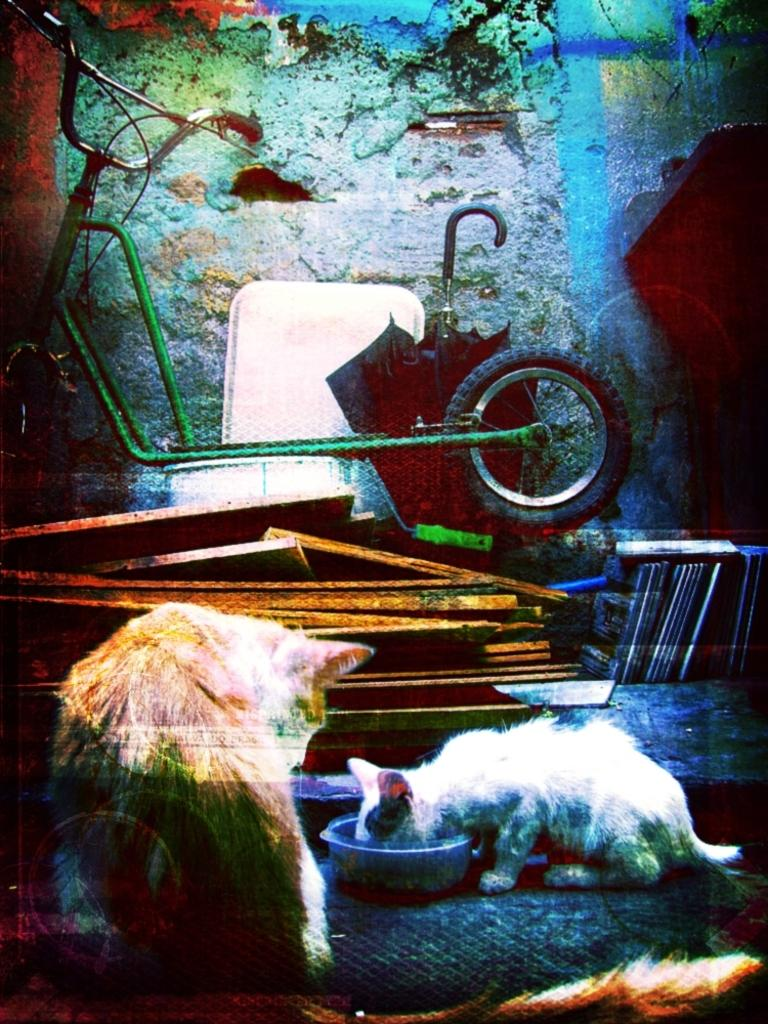How many cats are present in the image? There are two cats in the image. What object can be used for protection against rain in the image? There is an umbrella in the image. What can be used for holding food or liquids in the image? There is a bowl in the image. What mode of transportation can be seen in the image? There is a bicycle in the image. What type of structure is visible in the image? There is a wall in the image. What type of suit or skirt is worn by the cats in the image? There are no suits or skirts present in the image, as the subjects are cats. 